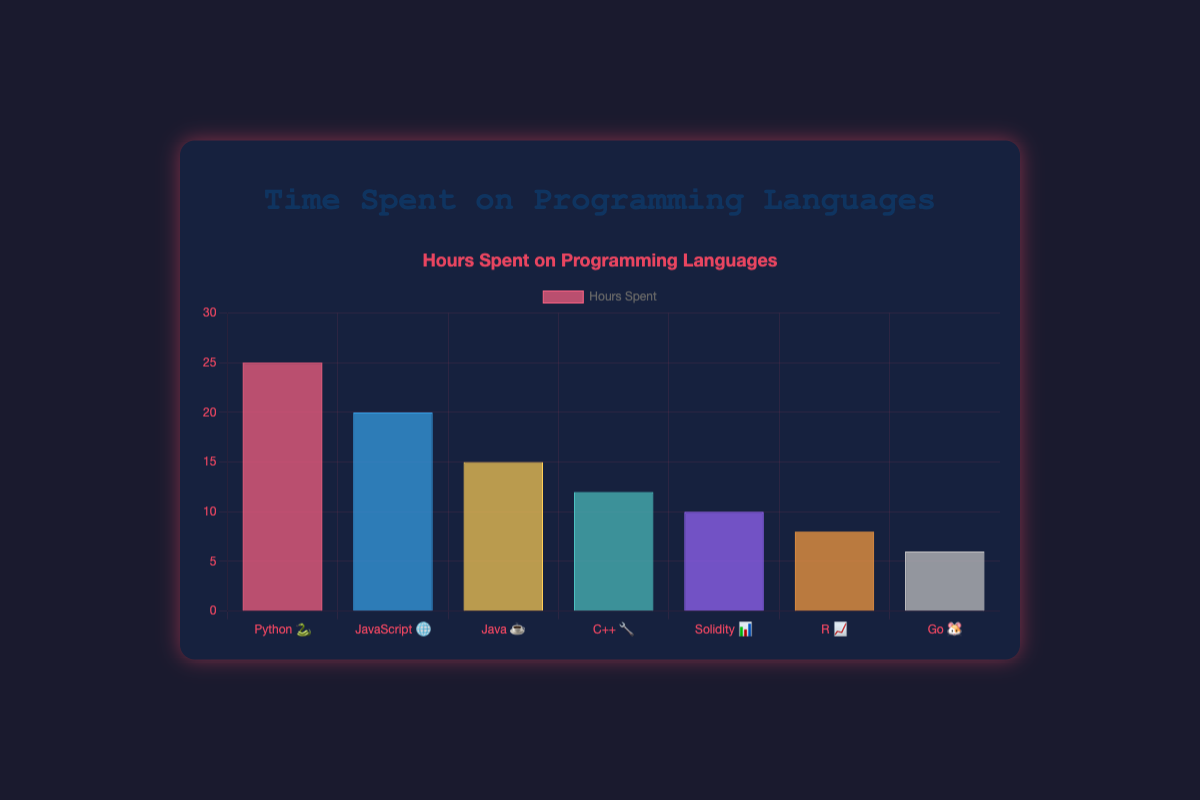What is the title of the chart? The title is displayed at the top of the chart center-aligned.
Answer: Time Spent on Programming Languages How many hours are spent on JavaScript 🌐? The bar representing JavaScript 🌐 shows the height at the 20-hour mark.
Answer: 20 hours Which language has the maximum hours spent? By looking at the height of the bars, the highest bar corresponds to Python 🐍.
Answer: Python 🐍 How many hours in total are spent on Java ☕ and C++ 🔧 combined? Java ☕ has 15 hours and C++ 🔧 has 12 hours. Adding them gives 15 + 12 = 27 hours.
Answer: 27 hours Which languages have less than 10 hours spent? The bars for R 📈 and Go 🐹 are below the 10-hour line.
Answer: R 📈 and Go 🐹 What is the difference in hours spent between Python 🐍 and Solidity 📊? Python 🐍 has 25 hours and Solidity 📊 has 10 hours. The difference is 25 - 10 = 15 hours.
Answer: 15 hours What is the average time spent on Java ☕, C++ 🔧, and Go 🐹? Java ☕ is 15 hours, C++ 🔧 is 12 hours, and Go 🐹 is 6 hours. Sum them up: 15 + 12 + 6 = 33 hours. Divide by 3 to get the average: 33 / 3 = 11 hours.
Answer: 11 hours How many languages have more than 15 hours spent? The bars for Python 🐍 and JavaScript 🌐 are above the 15-hour line.
Answer: 2 languages Which language has the second lowest hours spent? The lowest bar is Go 🐹, and the next lowest bar is R 📈.
Answer: R 📈 What percentage of the total hours is spent on Solidity 📊? The total hours are 25 + 20 + 15 + 12 + 10 + 8 + 6 = 96 hours. Solidity 📊 has 10 hours. The percentage is (10 / 96) * 100 ≈ 10.42%.
Answer: Approximately 10.42% 